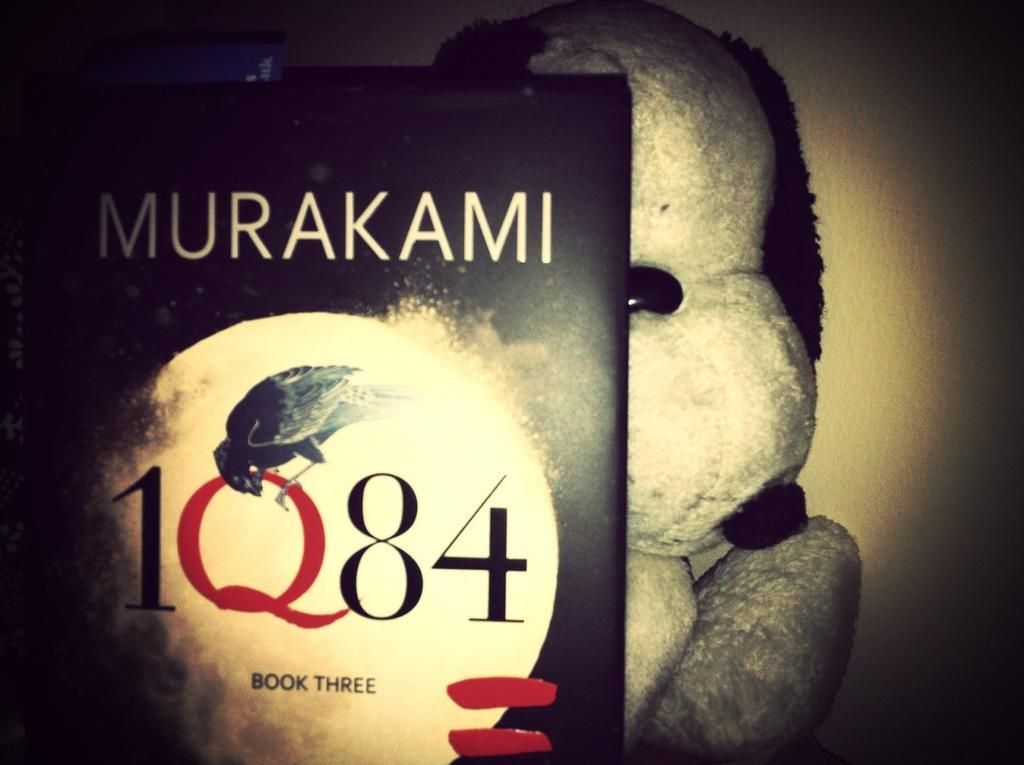<image>
Summarize the visual content of the image. a copy of the book murakami 1Q84 book three with a stuffed animal behind it. 